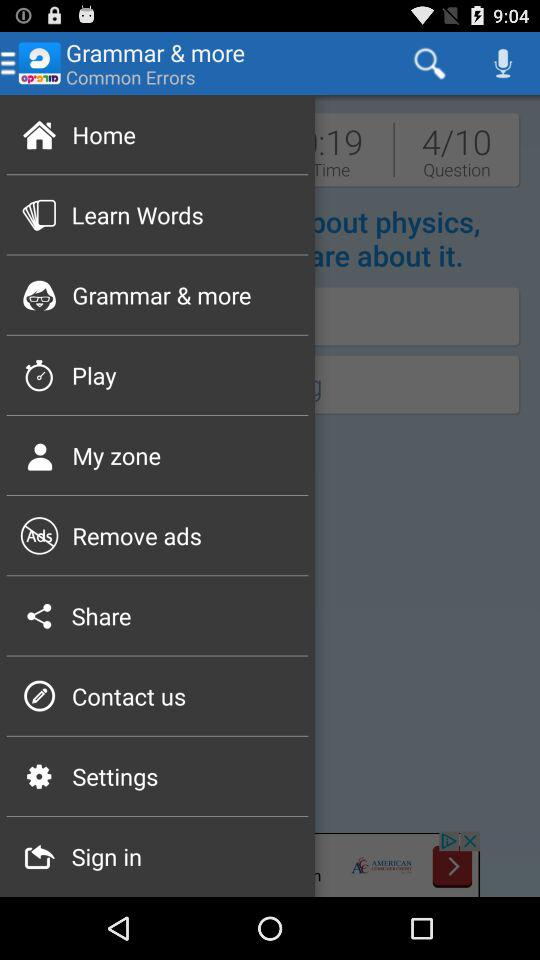How many questions in total are there? There are 10 questions. 